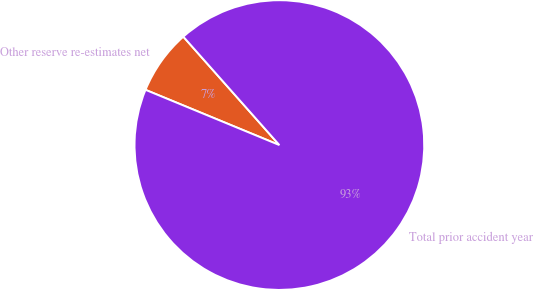Convert chart. <chart><loc_0><loc_0><loc_500><loc_500><pie_chart><fcel>Other reserve re-estimates net<fcel>Total prior accident year<nl><fcel>7.23%<fcel>92.77%<nl></chart> 